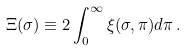<formula> <loc_0><loc_0><loc_500><loc_500>\Xi ( \sigma ) \equiv 2 \int _ { 0 } ^ { \infty } \xi ( \sigma , \pi ) d \pi \, .</formula> 